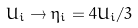Convert formula to latex. <formula><loc_0><loc_0><loc_500><loc_500>U _ { i } \rightarrow \eta _ { i } = 4 U _ { i } / 3</formula> 